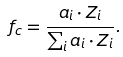<formula> <loc_0><loc_0><loc_500><loc_500>f _ { c } = \frac { a _ { i } \cdot Z _ { i } } { \sum _ { i } a _ { i } \cdot Z _ { i } } .</formula> 